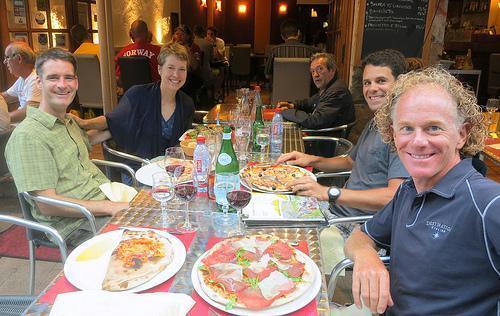How many people on the right side?
Give a very brief answer. 3. How many green bottles are on the table?
Give a very brief answer. 2. 